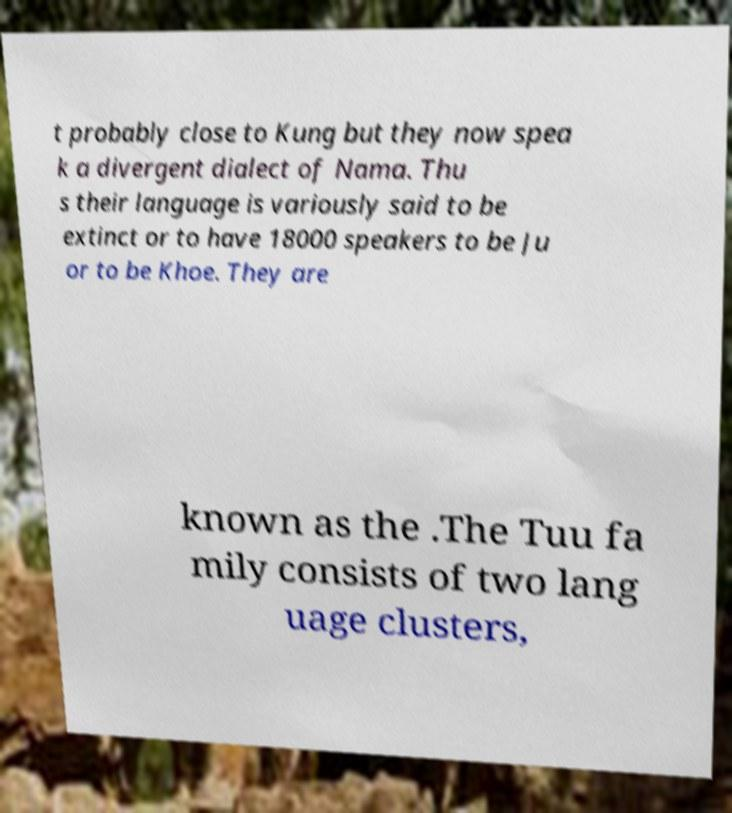Can you accurately transcribe the text from the provided image for me? t probably close to Kung but they now spea k a divergent dialect of Nama. Thu s their language is variously said to be extinct or to have 18000 speakers to be Ju or to be Khoe. They are known as the .The Tuu fa mily consists of two lang uage clusters, 